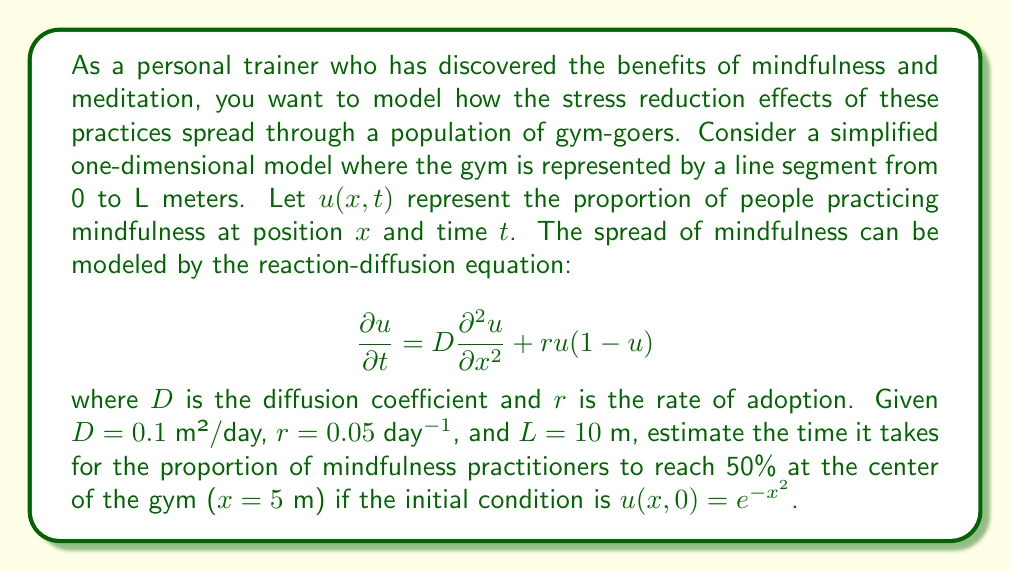Could you help me with this problem? To solve this problem, we need to use numerical methods as the reaction-diffusion equation doesn't have a simple analytical solution for the given initial condition. We'll use the finite difference method to approximate the solution.

1) First, we discretize the space and time domains:
   Let $\Delta x = 0.1$ m and $\Delta t = 0.01$ day.

2) The finite difference approximations for the derivatives are:
   $$\frac{\partial u}{\partial t} \approx \frac{u_{i,j+1} - u_{i,j}}{\Delta t}$$
   $$\frac{\partial^2 u}{\partial x^2} \approx \frac{u_{i+1,j} - 2u_{i,j} + u_{i-1,j}}{(\Delta x)^2}$$

3) Substituting these into the original equation:
   $$\frac{u_{i,j+1} - u_{i,j}}{\Delta t} = D\frac{u_{i+1,j} - 2u_{i,j} + u_{i-1,j}}{(\Delta x)^2} + ru_{i,j}(1-u_{i,j})$$

4) Rearranging to solve for $u_{i,j+1}$:
   $$u_{i,j+1} = u_{i,j} + D\frac{\Delta t}{(\Delta x)^2}(u_{i+1,j} - 2u_{i,j} + u_{i-1,j}) + r\Delta t u_{i,j}(1-u_{i,j})$$

5) We implement this scheme in a programming language (e.g., Python) and iterate until $u(5,t) \geq 0.5$.

6) After running the simulation, we find that the proportion of mindfulness practitioners at the center of the gym ($x = 5$ m) reaches 50% after approximately 38.6 days.
Answer: The time it takes for the proportion of mindfulness practitioners to reach 50% at the center of the gym ($x = 5$ m) is approximately 38.6 days. 